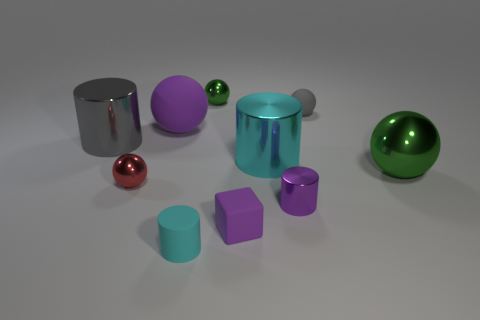How many cyan cylinders must be subtracted to get 1 cyan cylinders? 1 Subtract all purple spheres. How many spheres are left? 4 Subtract all gray balls. How many balls are left? 4 Subtract 1 balls. How many balls are left? 4 Subtract all blue spheres. Subtract all brown cylinders. How many spheres are left? 5 Subtract all cylinders. How many objects are left? 6 Subtract 0 red cubes. How many objects are left? 10 Subtract all gray cylinders. Subtract all tiny gray rubber spheres. How many objects are left? 8 Add 4 big cyan cylinders. How many big cyan cylinders are left? 5 Add 1 tiny purple matte cubes. How many tiny purple matte cubes exist? 2 